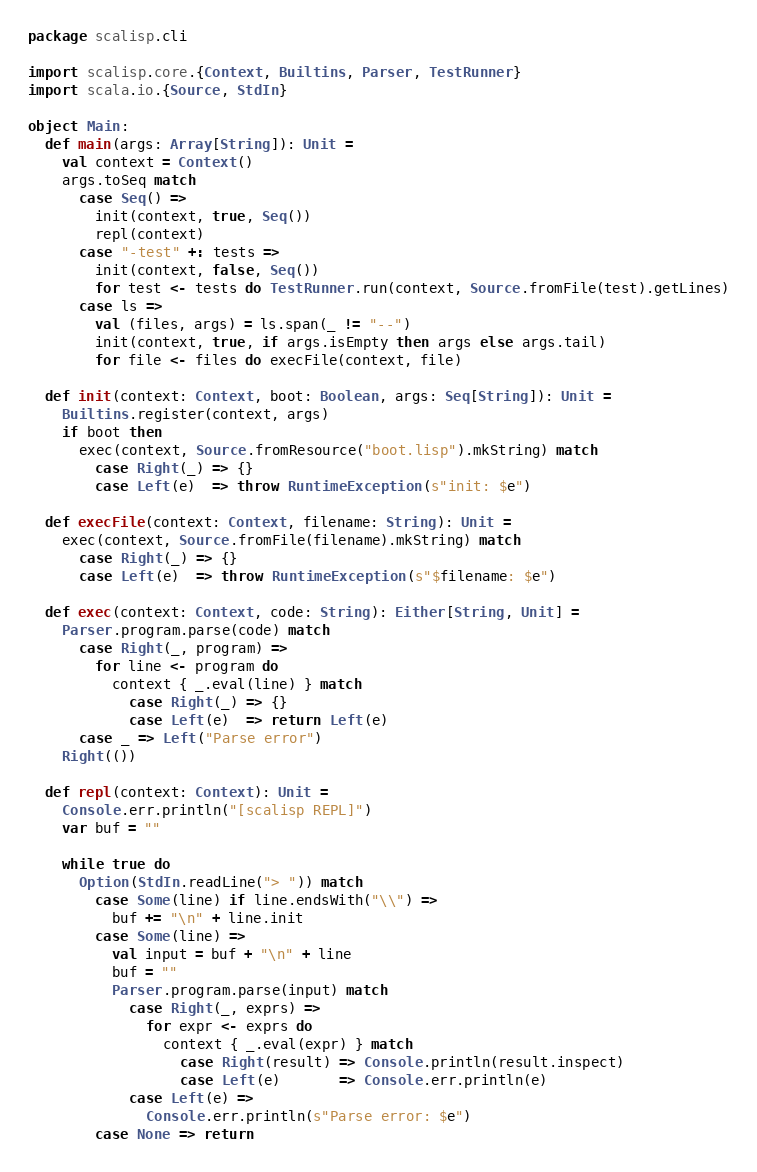<code> <loc_0><loc_0><loc_500><loc_500><_Scala_>package scalisp.cli

import scalisp.core.{Context, Builtins, Parser, TestRunner}
import scala.io.{Source, StdIn}

object Main:
  def main(args: Array[String]): Unit =
    val context = Context()
    args.toSeq match
      case Seq() =>
        init(context, true, Seq())
        repl(context)
      case "-test" +: tests =>
        init(context, false, Seq())
        for test <- tests do TestRunner.run(context, Source.fromFile(test).getLines)
      case ls =>
        val (files, args) = ls.span(_ != "--")
        init(context, true, if args.isEmpty then args else args.tail)
        for file <- files do execFile(context, file)

  def init(context: Context, boot: Boolean, args: Seq[String]): Unit =
    Builtins.register(context, args)
    if boot then
      exec(context, Source.fromResource("boot.lisp").mkString) match
        case Right(_) => {}
        case Left(e)  => throw RuntimeException(s"init: $e")

  def execFile(context: Context, filename: String): Unit =
    exec(context, Source.fromFile(filename).mkString) match
      case Right(_) => {}
      case Left(e)  => throw RuntimeException(s"$filename: $e")

  def exec(context: Context, code: String): Either[String, Unit] =
    Parser.program.parse(code) match
      case Right(_, program) =>
        for line <- program do
          context { _.eval(line) } match
            case Right(_) => {}
            case Left(e)  => return Left(e)
      case _ => Left("Parse error")
    Right(())

  def repl(context: Context): Unit =
    Console.err.println("[scalisp REPL]")
    var buf = ""

    while true do
      Option(StdIn.readLine("> ")) match
        case Some(line) if line.endsWith("\\") =>
          buf += "\n" + line.init
        case Some(line) =>
          val input = buf + "\n" + line
          buf = ""
          Parser.program.parse(input) match
            case Right(_, exprs) =>
              for expr <- exprs do
                context { _.eval(expr) } match
                  case Right(result) => Console.println(result.inspect)
                  case Left(e)       => Console.err.println(e)
            case Left(e) =>
              Console.err.println(s"Parse error: $e")
        case None => return
</code> 